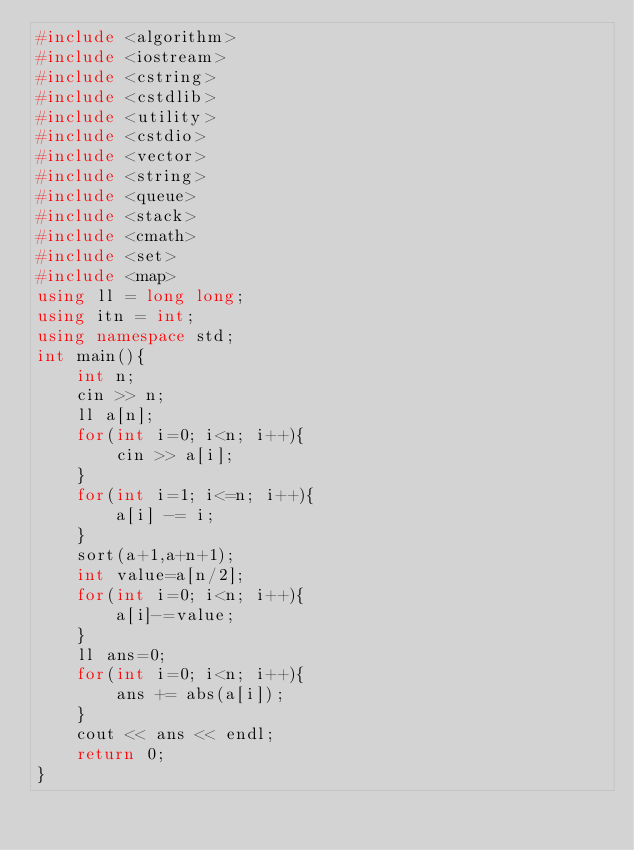<code> <loc_0><loc_0><loc_500><loc_500><_C++_>#include <algorithm>
#include <iostream>
#include <cstring>
#include <cstdlib>
#include <utility>
#include <cstdio>
#include <vector>
#include <string>
#include <queue>
#include <stack>
#include <cmath>
#include <set>
#include <map>
using ll = long long;
using itn = int;
using namespace std;
int main(){
    int n;
    cin >> n;
    ll a[n];
    for(int i=0; i<n; i++){
        cin >> a[i];
    }
    for(int i=1; i<=n; i++){
        a[i] -= i;
    }
    sort(a+1,a+n+1);
    int value=a[n/2];
    for(int i=0; i<n; i++){
        a[i]-=value;
    }
    ll ans=0;
    for(int i=0; i<n; i++){
        ans += abs(a[i]);
    }
    cout << ans << endl;
    return 0;
}
</code> 